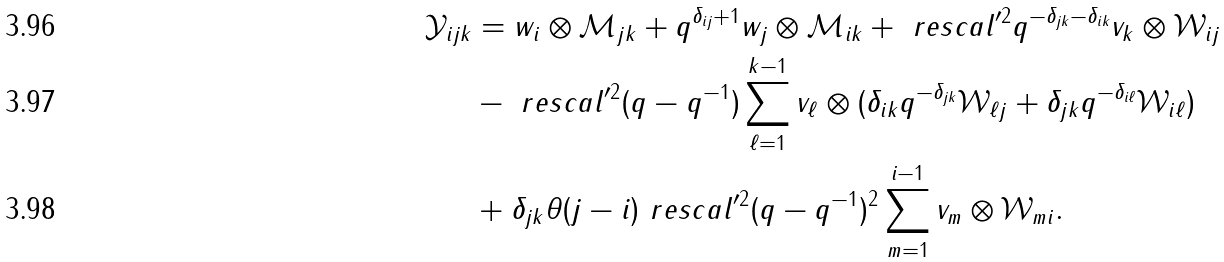<formula> <loc_0><loc_0><loc_500><loc_500>\mathcal { Y } _ { i j k } & = w _ { i } \otimes \mathcal { M } _ { j k } + q ^ { \delta _ { i j } + 1 } w _ { j } \otimes \mathcal { M } _ { i k } + \ r e s c a l ^ { \prime 2 } q ^ { - \delta _ { j k } - \delta _ { i k } } v _ { k } \otimes \mathcal { W } _ { i j } \\ & - \ r e s c a l ^ { \prime 2 } ( q - q ^ { - 1 } ) \sum _ { \ell = 1 } ^ { k - 1 } v _ { \ell } \otimes ( \delta _ { i k } q ^ { - \delta _ { j k } } \mathcal { W } _ { \ell j } + \delta _ { j k } q ^ { - \delta _ { i \ell } } \mathcal { W } _ { i \ell } ) \\ & + \delta _ { j k } \theta ( j - i ) \ r e s c a l ^ { \prime 2 } ( q - q ^ { - 1 } ) ^ { 2 } \sum _ { m = 1 } ^ { i - 1 } v _ { m } \otimes \mathcal { W } _ { m i } .</formula> 